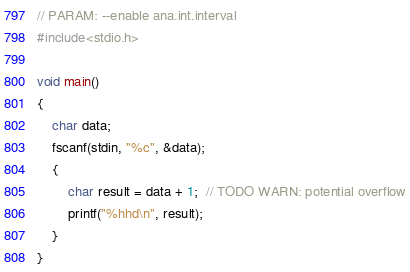<code> <loc_0><loc_0><loc_500><loc_500><_C_>// PARAM: --enable ana.int.interval
#include<stdio.h>

void main()
{
    char data;
    fscanf(stdin, "%c", &data);
    {
        char result = data + 1;  // TODO WARN: potential overflow
        printf("%hhd\n", result);
    }
}
</code> 